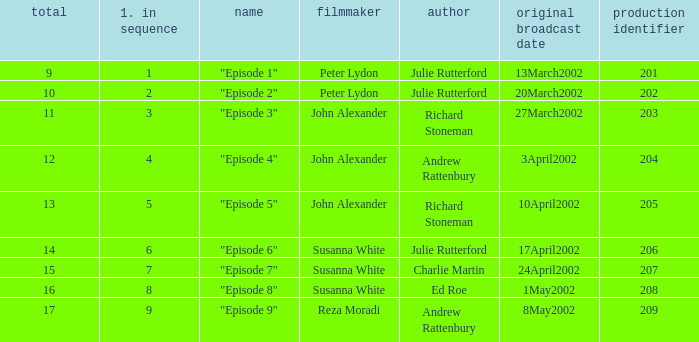When 15 is the number overall what is the original air date? 24April2002. Could you parse the entire table as a dict? {'header': ['total', '1. in sequence', 'name', 'filmmaker', 'author', 'original broadcast date', 'production identifier'], 'rows': [['9', '1', '"Episode 1"', 'Peter Lydon', 'Julie Rutterford', '13March2002', '201'], ['10', '2', '"Episode 2"', 'Peter Lydon', 'Julie Rutterford', '20March2002', '202'], ['11', '3', '"Episode 3"', 'John Alexander', 'Richard Stoneman', '27March2002', '203'], ['12', '4', '"Episode 4"', 'John Alexander', 'Andrew Rattenbury', '3April2002', '204'], ['13', '5', '"Episode 5"', 'John Alexander', 'Richard Stoneman', '10April2002', '205'], ['14', '6', '"Episode 6"', 'Susanna White', 'Julie Rutterford', '17April2002', '206'], ['15', '7', '"Episode 7"', 'Susanna White', 'Charlie Martin', '24April2002', '207'], ['16', '8', '"Episode 8"', 'Susanna White', 'Ed Roe', '1May2002', '208'], ['17', '9', '"Episode 9"', 'Reza Moradi', 'Andrew Rattenbury', '8May2002', '209']]} 